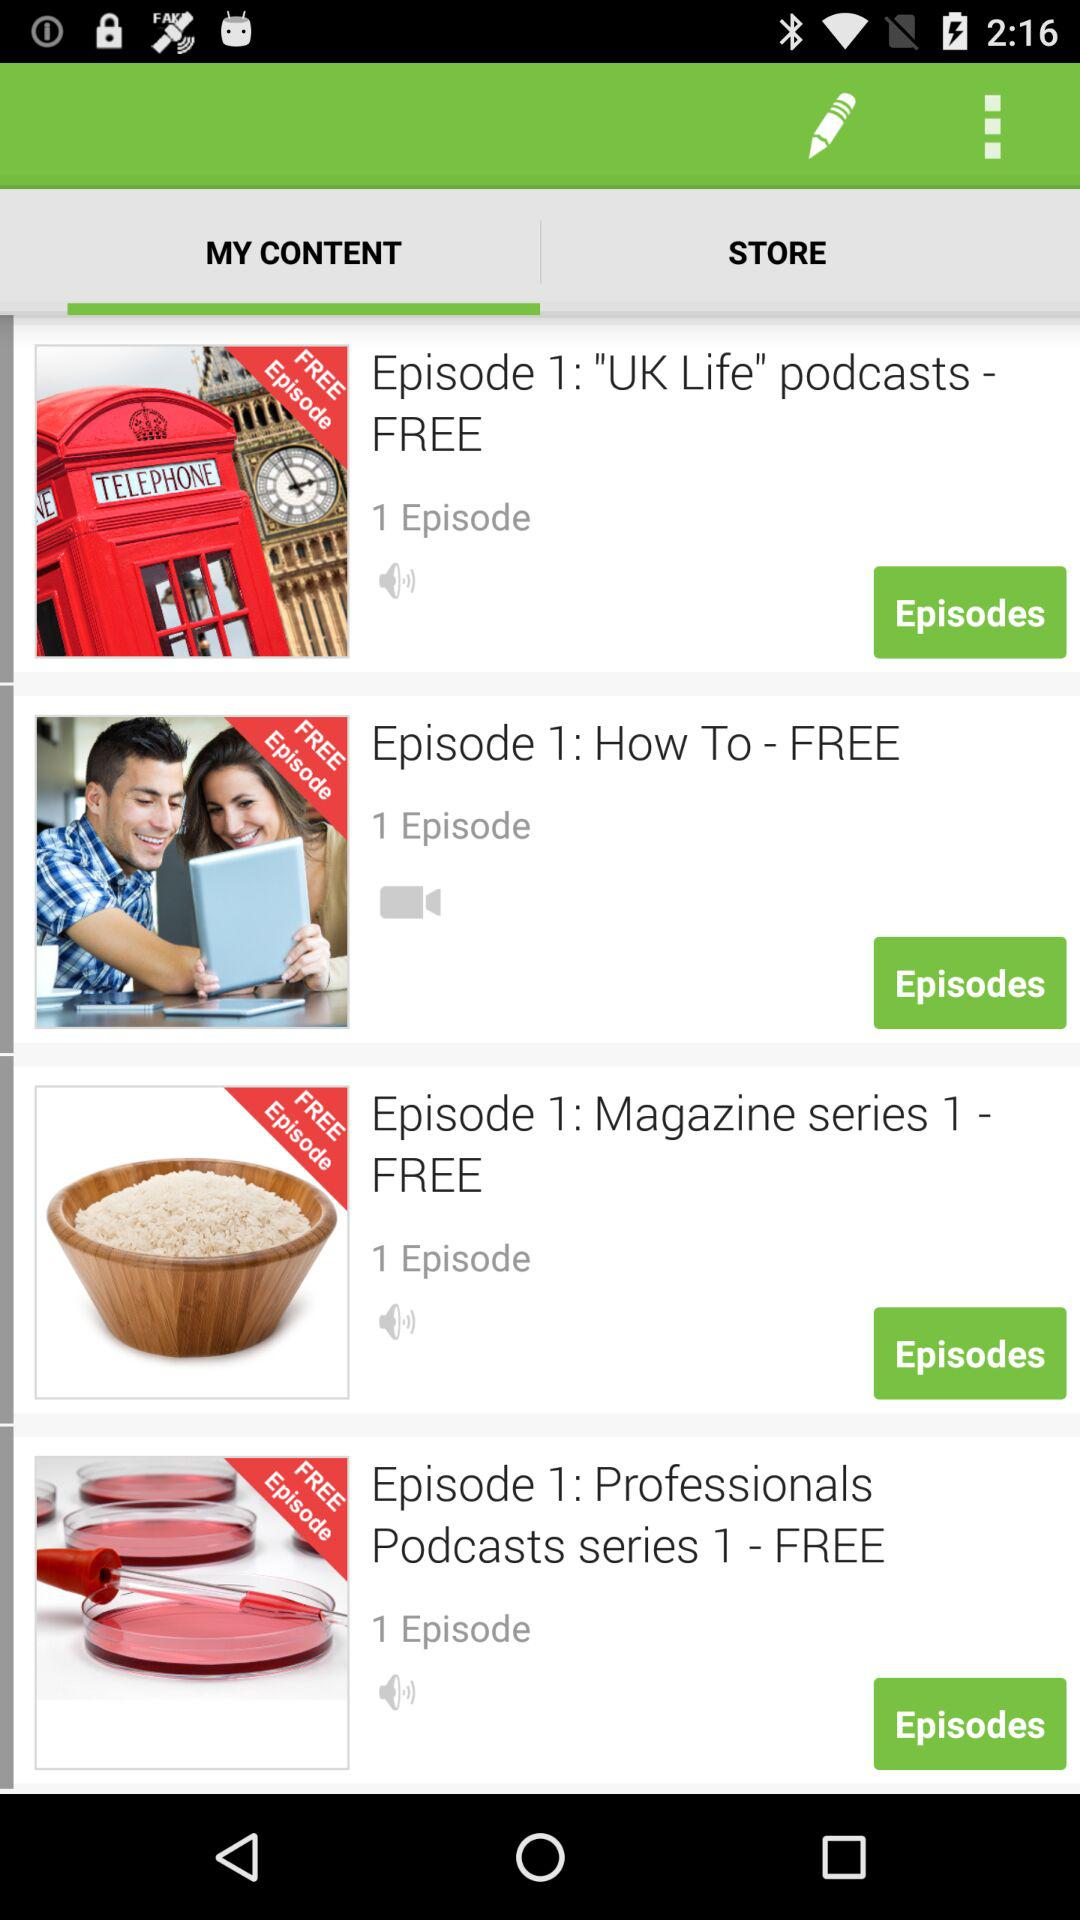Which is the selected tab? The selected tab is "MY CONTENT". 